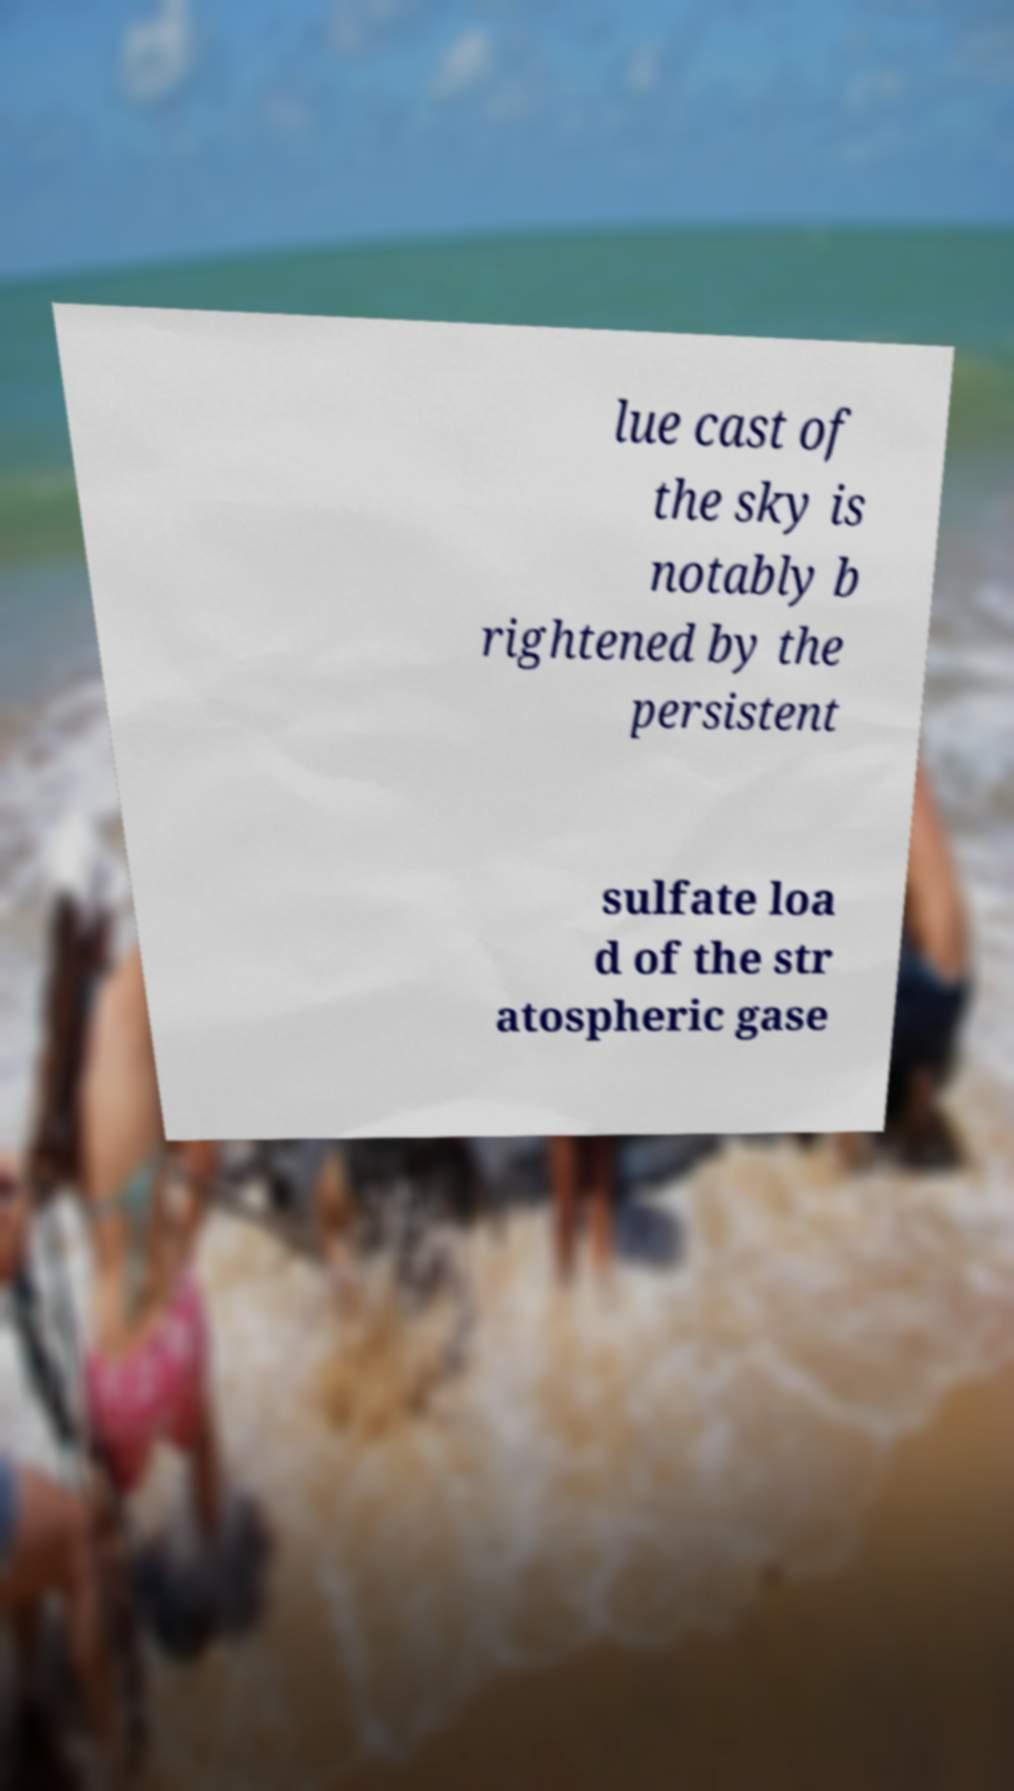For documentation purposes, I need the text within this image transcribed. Could you provide that? lue cast of the sky is notably b rightened by the persistent sulfate loa d of the str atospheric gase 